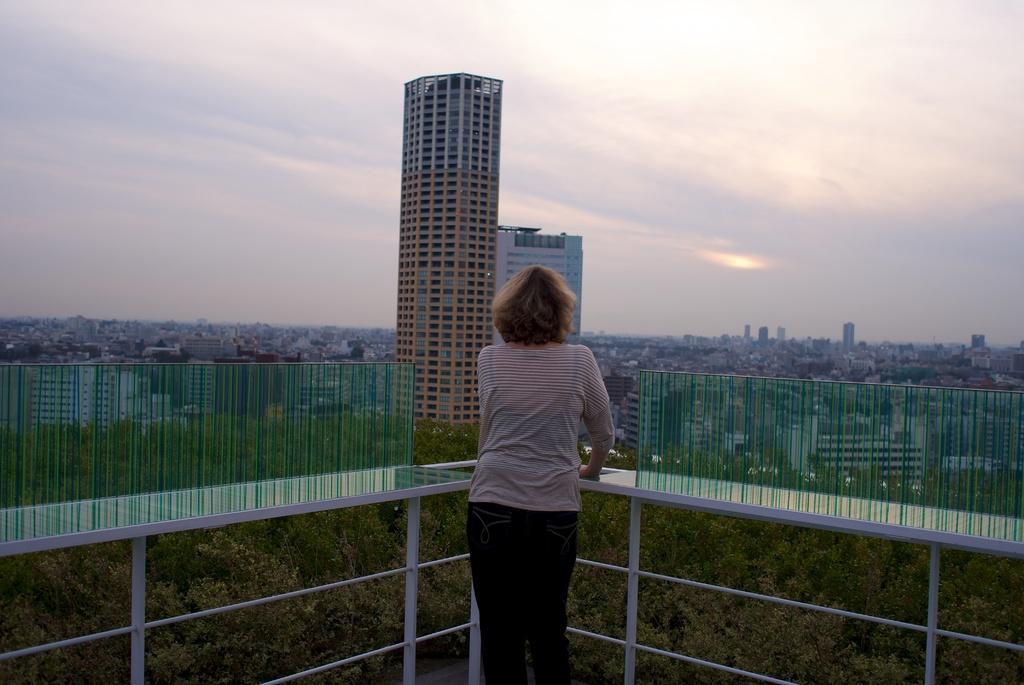Please provide a concise description of this image. In this image we can see a woman standing by holding the grills, buildings, trees, skyscrapers and sky with clouds. 